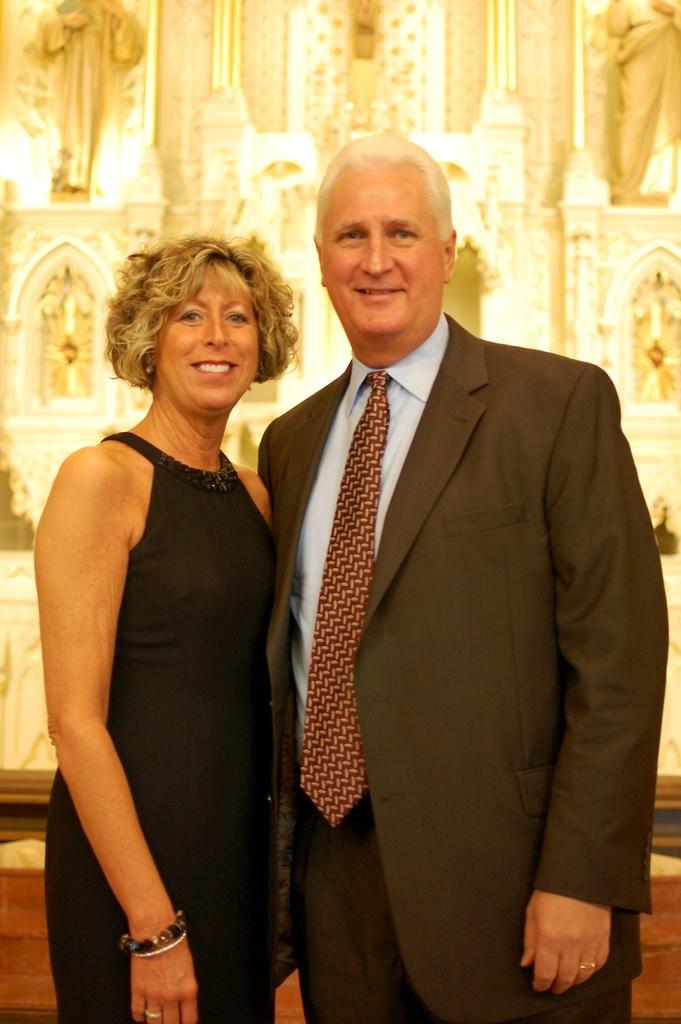How many people are in the image? There are two persons in the image. What are the persons doing in the image? The persons are standing and smiling. What can be seen in the background of the image? There are statues and a wall in the background of the image. What type of ink is being used by the person on the left in the image? There is no ink or writing activity present in the image; the persons are simply standing and smiling. 